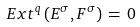<formula> <loc_0><loc_0><loc_500><loc_500>E x t ^ { q } \left ( E ^ { \sigma } , F ^ { \sigma } \right ) \, = \, 0</formula> 